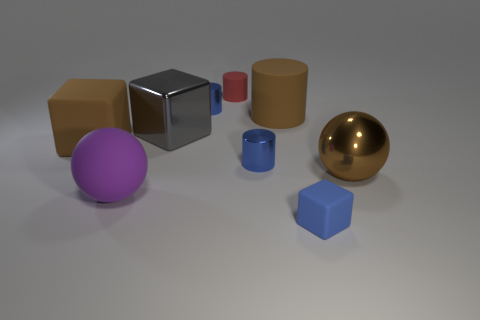Are there more blue matte blocks that are behind the big brown metallic ball than purple rubber balls right of the tiny red cylinder?
Give a very brief answer. No. There is a ball that is the same color as the big cylinder; what material is it?
Make the answer very short. Metal. What number of tiny matte cubes are the same color as the large rubber cube?
Keep it short and to the point. 0. There is a rubber block that is behind the tiny block; does it have the same color as the big rubber object that is to the right of the purple ball?
Keep it short and to the point. Yes. Are there any rubber things left of the brown matte block?
Provide a succinct answer. No. What material is the big gray thing?
Offer a terse response. Metal. The small blue metal object in front of the big gray thing has what shape?
Give a very brief answer. Cylinder. Is there a cyan object of the same size as the brown matte cylinder?
Ensure brevity in your answer.  No. Are the large ball that is to the left of the small blue rubber thing and the tiny red cylinder made of the same material?
Keep it short and to the point. Yes. Is the number of gray shiny cubes behind the red matte thing the same as the number of large balls that are in front of the gray object?
Provide a succinct answer. No. 